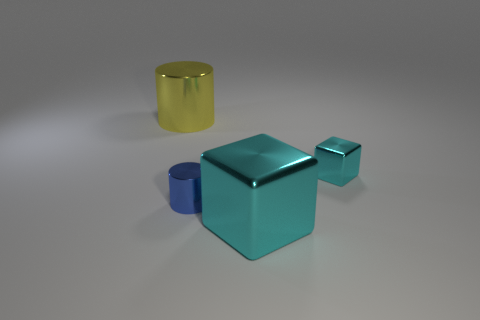The thing that is the same color as the large metallic cube is what size?
Offer a very short reply. Small. There is a large thing that is to the right of the big yellow thing; how many big cyan blocks are behind it?
Give a very brief answer. 0. Is the size of the blue object the same as the cyan metallic cube that is to the right of the large cyan shiny cube?
Ensure brevity in your answer.  Yes. Is there a small metal cube that has the same color as the big shiny cylinder?
Your response must be concise. No. There is another cylinder that is made of the same material as the big cylinder; what size is it?
Give a very brief answer. Small. Does the tiny cylinder have the same material as the tiny cyan cube?
Offer a very short reply. Yes. There is a tiny shiny thing that is to the left of the large cube that is right of the big shiny thing behind the small shiny cube; what color is it?
Ensure brevity in your answer.  Blue. The blue shiny object is what shape?
Your response must be concise. Cylinder. There is a tiny shiny cylinder; is it the same color as the big metallic object in front of the yellow shiny thing?
Provide a succinct answer. No. Is the number of tiny cyan metal things in front of the blue shiny cylinder the same as the number of cyan things?
Make the answer very short. No. 